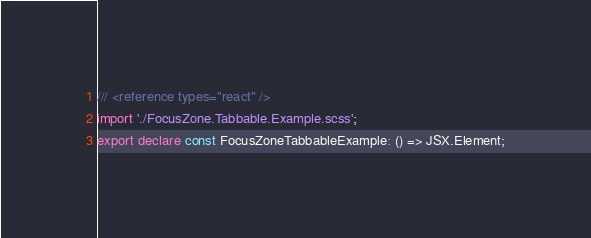<code> <loc_0><loc_0><loc_500><loc_500><_TypeScript_>/// <reference types="react" />
import './FocusZone.Tabbable.Example.scss';
export declare const FocusZoneTabbableExample: () => JSX.Element;
</code> 